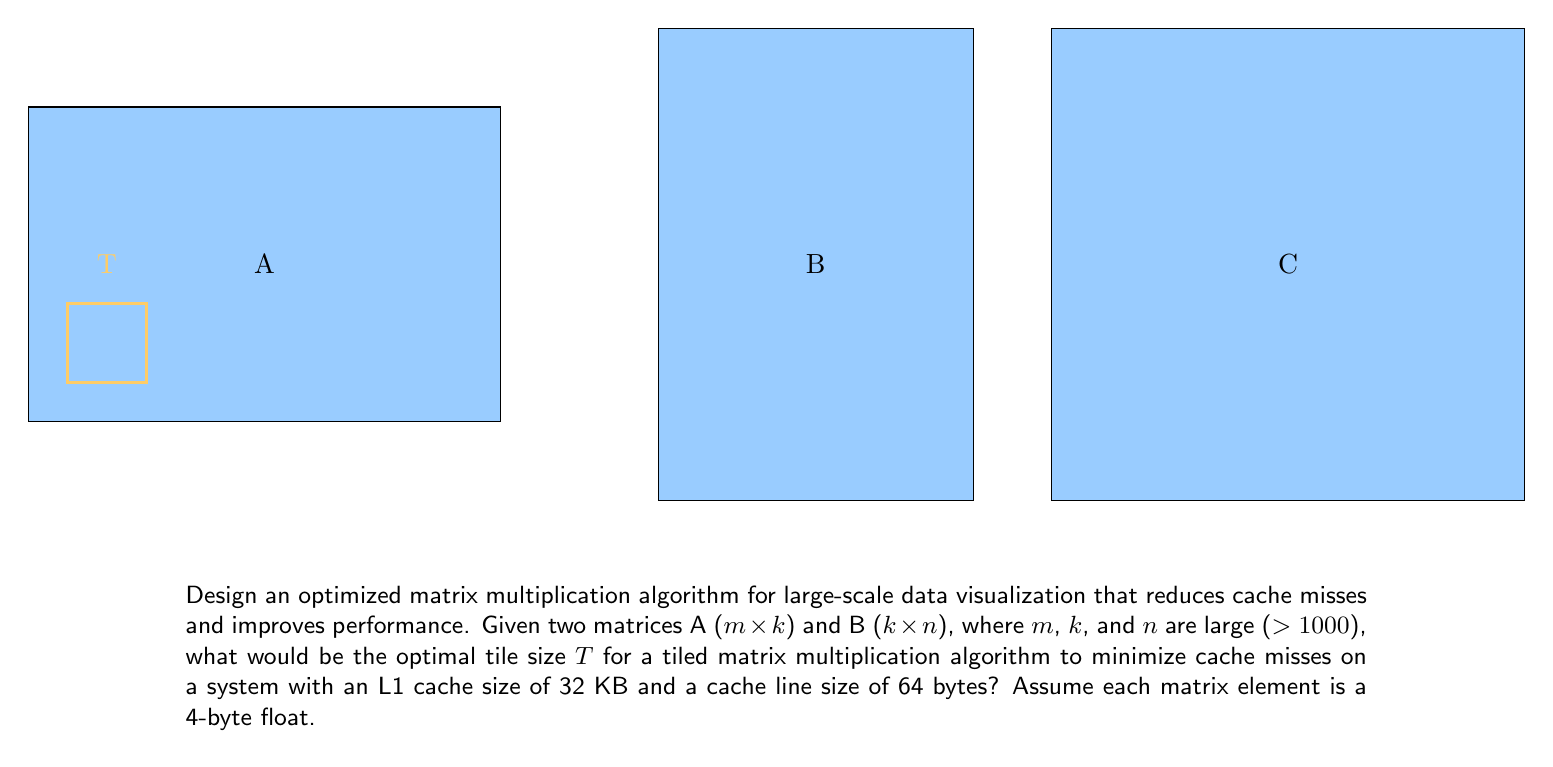Give your solution to this math problem. To optimize matrix multiplication for large-scale data visualization, we need to minimize cache misses by choosing an appropriate tile size. Let's approach this step-by-step:

1) First, we need to calculate how many matrix elements can fit in one cache line:
   Cache line size = 64 bytes
   Size of each element = 4 bytes
   Elements per cache line = 64 / 4 = 16 elements

2) Now, let's consider a tile of size T x T. For optimal cache usage, we want three tiles (one from each matrix A, B, and the result matrix C) to fit in the L1 cache simultaneously.

3) The space required for three T x T tiles is:
   $3 \times T \times T \times 4$ bytes

4) This should be less than or equal to the L1 cache size:
   $3 \times T \times T \times 4 \leq 32 \times 1024$ bytes

5) Solving for T:
   $3T^2 \times 4 \leq 32768$
   $T^2 \leq 2730.67$
   $T \leq \sqrt{2730.67} \approx 52.26$

6) However, we also want T to be a multiple of the number of elements per cache line (16) to avoid splitting cache lines. The largest multiple of 16 not exceeding 52 is 48.

7) Therefore, the optimal tile size T is 48 x 48 elements.

This tile size will ensure that we can keep one tile from each matrix in the L1 cache simultaneously, minimizing cache misses and optimizing performance for large-scale data visualization.
Answer: 48 